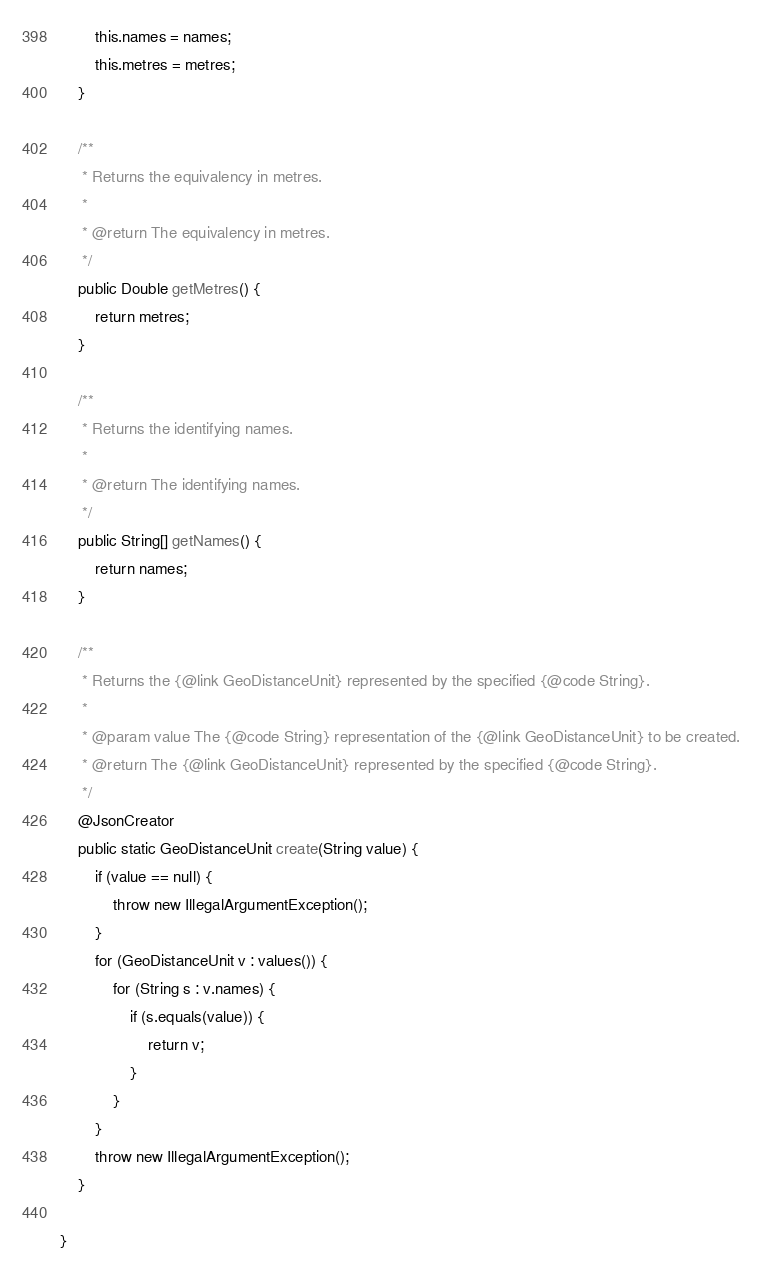<code> <loc_0><loc_0><loc_500><loc_500><_Java_>        this.names = names;
        this.metres = metres;
    }

    /**
     * Returns the equivalency in metres.
     *
     * @return The equivalency in metres.
     */
    public Double getMetres() {
        return metres;
    }

    /**
     * Returns the identifying names.
     *
     * @return The identifying names.
     */
    public String[] getNames() {
        return names;
    }

    /**
     * Returns the {@link GeoDistanceUnit} represented by the specified {@code String}.
     *
     * @param value The {@code String} representation of the {@link GeoDistanceUnit} to be created.
     * @return The {@link GeoDistanceUnit} represented by the specified {@code String}.
     */
    @JsonCreator
    public static GeoDistanceUnit create(String value) {
        if (value == null) {
            throw new IllegalArgumentException();
        }
        for (GeoDistanceUnit v : values()) {
            for (String s : v.names) {
                if (s.equals(value)) {
                    return v;
                }
            }
        }
        throw new IllegalArgumentException();
    }

}
</code> 